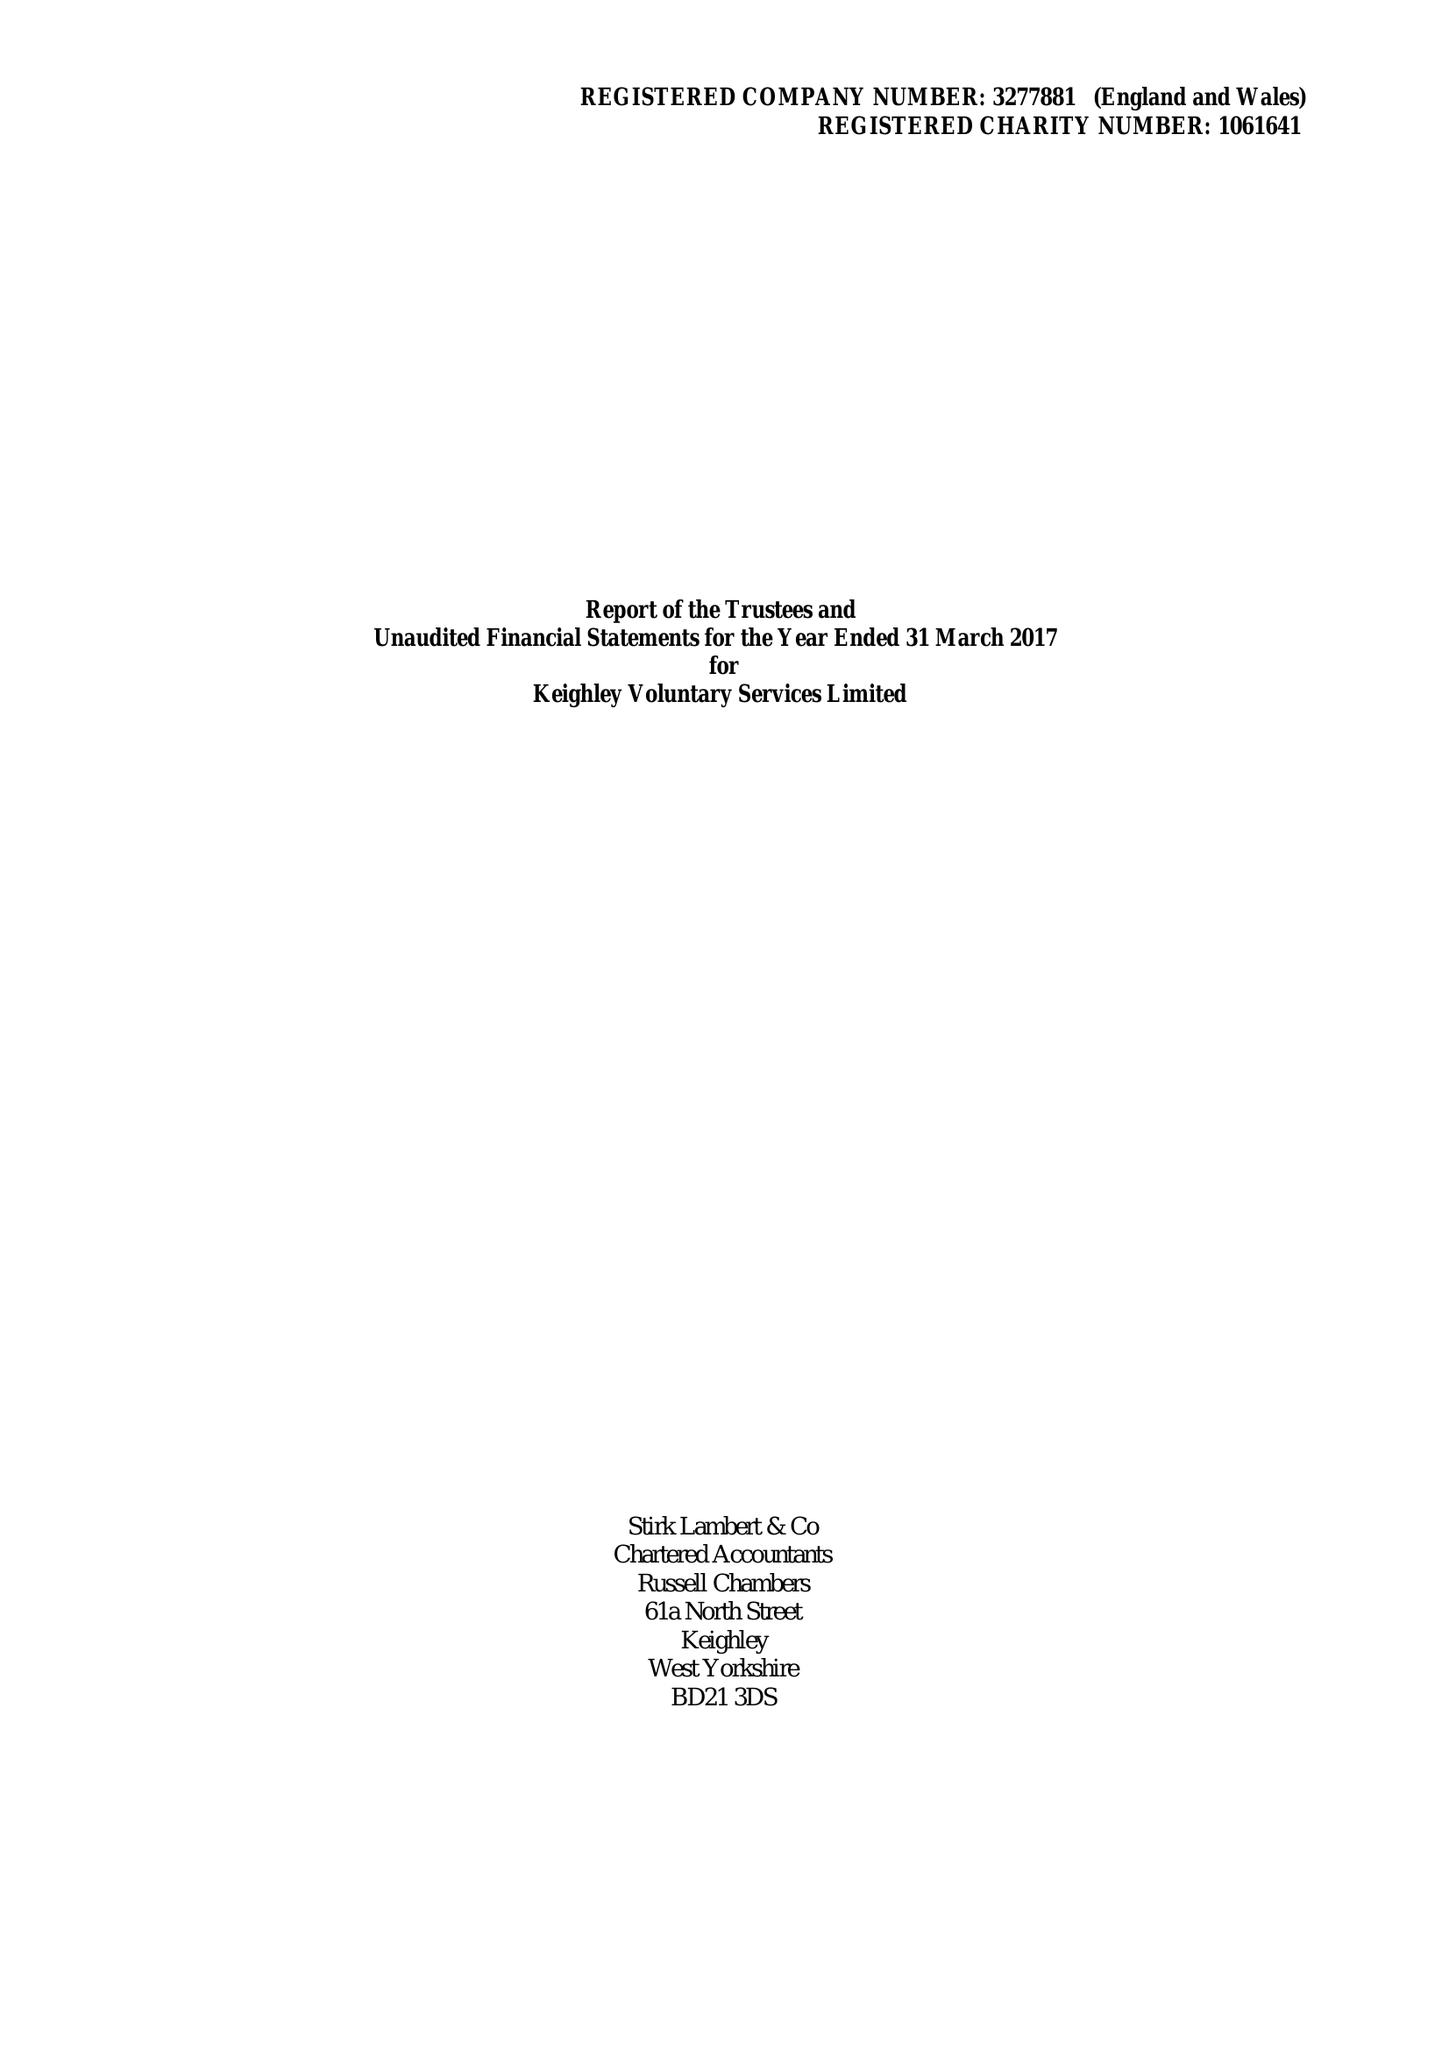What is the value for the address__post_town?
Answer the question using a single word or phrase. KEIGHLEY 